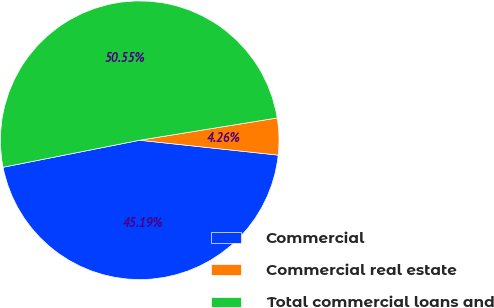Convert chart. <chart><loc_0><loc_0><loc_500><loc_500><pie_chart><fcel>Commercial<fcel>Commercial real estate<fcel>Total commercial loans and<nl><fcel>45.19%<fcel>4.26%<fcel>50.55%<nl></chart> 